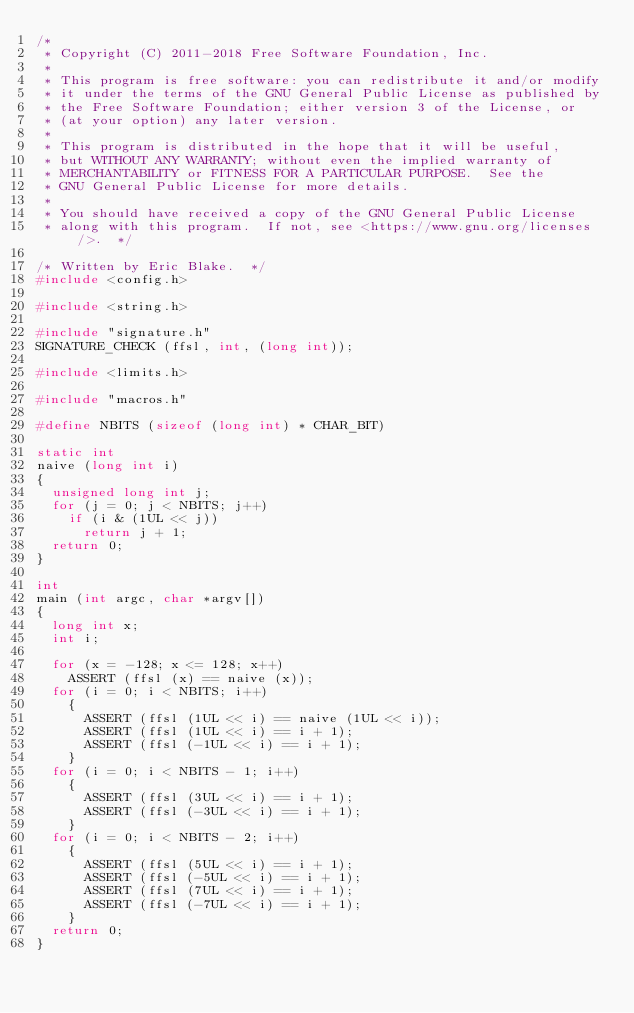Convert code to text. <code><loc_0><loc_0><loc_500><loc_500><_C_>/*
 * Copyright (C) 2011-2018 Free Software Foundation, Inc.
 *
 * This program is free software: you can redistribute it and/or modify
 * it under the terms of the GNU General Public License as published by
 * the Free Software Foundation; either version 3 of the License, or
 * (at your option) any later version.
 *
 * This program is distributed in the hope that it will be useful,
 * but WITHOUT ANY WARRANTY; without even the implied warranty of
 * MERCHANTABILITY or FITNESS FOR A PARTICULAR PURPOSE.  See the
 * GNU General Public License for more details.
 *
 * You should have received a copy of the GNU General Public License
 * along with this program.  If not, see <https://www.gnu.org/licenses/>.  */

/* Written by Eric Blake.  */
#include <config.h>

#include <string.h>

#include "signature.h"
SIGNATURE_CHECK (ffsl, int, (long int));

#include <limits.h>

#include "macros.h"

#define NBITS (sizeof (long int) * CHAR_BIT)

static int
naive (long int i)
{
  unsigned long int j;
  for (j = 0; j < NBITS; j++)
    if (i & (1UL << j))
      return j + 1;
  return 0;
}

int
main (int argc, char *argv[])
{
  long int x;
  int i;

  for (x = -128; x <= 128; x++)
    ASSERT (ffsl (x) == naive (x));
  for (i = 0; i < NBITS; i++)
    {
      ASSERT (ffsl (1UL << i) == naive (1UL << i));
      ASSERT (ffsl (1UL << i) == i + 1);
      ASSERT (ffsl (-1UL << i) == i + 1);
    }
  for (i = 0; i < NBITS - 1; i++)
    {
      ASSERT (ffsl (3UL << i) == i + 1);
      ASSERT (ffsl (-3UL << i) == i + 1);
    }
  for (i = 0; i < NBITS - 2; i++)
    {
      ASSERT (ffsl (5UL << i) == i + 1);
      ASSERT (ffsl (-5UL << i) == i + 1);
      ASSERT (ffsl (7UL << i) == i + 1);
      ASSERT (ffsl (-7UL << i) == i + 1);
    }
  return 0;
}
</code> 